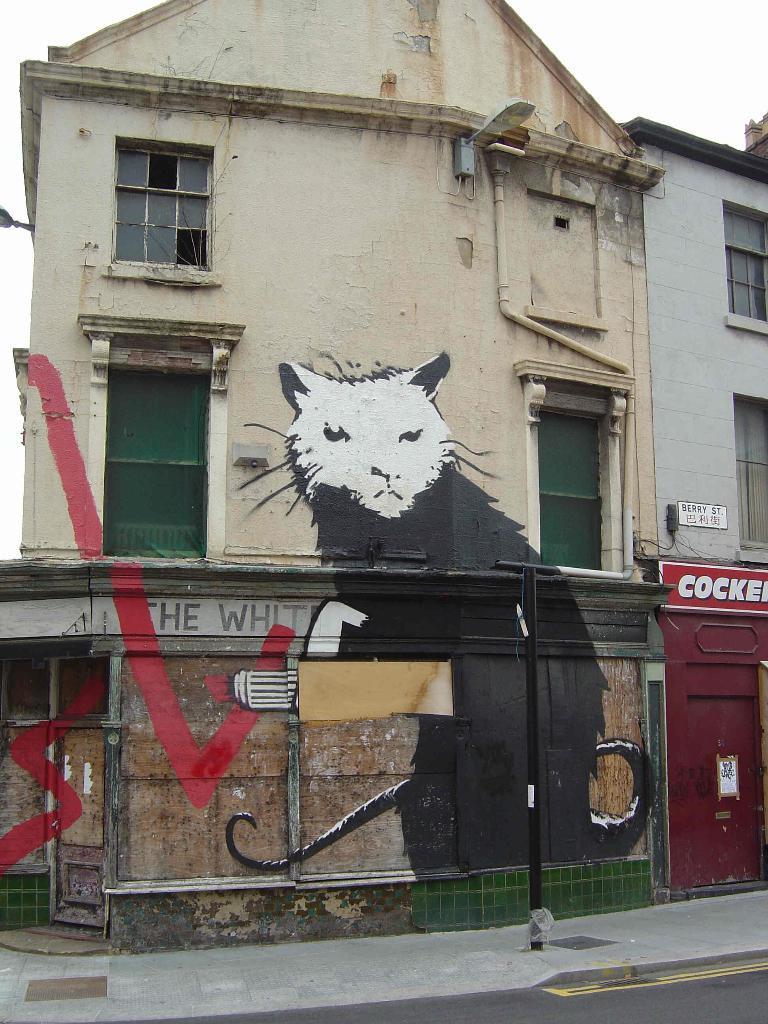Please provide a concise description of this image. In this image we can see the road, art on the wall building, board and the sky in the background. 